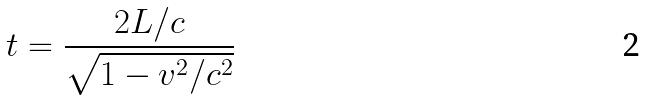Convert formula to latex. <formula><loc_0><loc_0><loc_500><loc_500>t = \frac { 2 L / c } { \sqrt { 1 - v ^ { 2 } / c ^ { 2 } } }</formula> 